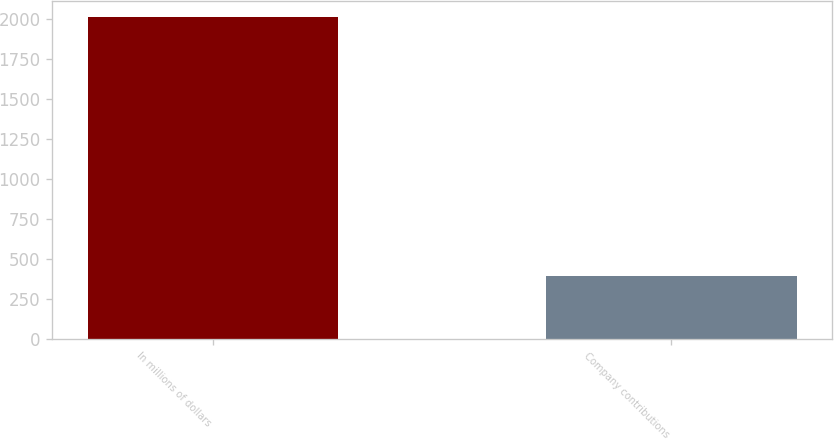Convert chart. <chart><loc_0><loc_0><loc_500><loc_500><bar_chart><fcel>In millions of dollars<fcel>Company contributions<nl><fcel>2013<fcel>394<nl></chart> 